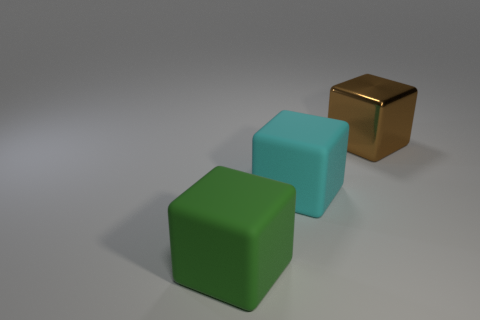Are there any other things that have the same material as the brown object?
Give a very brief answer. No. There is a brown object; what shape is it?
Offer a terse response. Cube. What is the size of the matte block that is right of the rubber thing left of the big matte thing to the right of the large green rubber object?
Your response must be concise. Large. Does the object behind the big cyan block have the same shape as the matte thing that is to the right of the large green thing?
Offer a very short reply. Yes. How many cubes are either matte things or red things?
Ensure brevity in your answer.  2. What is the material of the cube right of the rubber object behind the large green thing that is in front of the cyan matte thing?
Provide a short and direct response. Metal. How many other objects are there of the same size as the cyan block?
Your answer should be compact. 2. Is the number of metal things that are in front of the cyan block greater than the number of shiny blocks?
Make the answer very short. No. Are there any rubber things of the same color as the large metal block?
Ensure brevity in your answer.  No. There is a metal block that is the same size as the cyan object; what color is it?
Keep it short and to the point. Brown. 